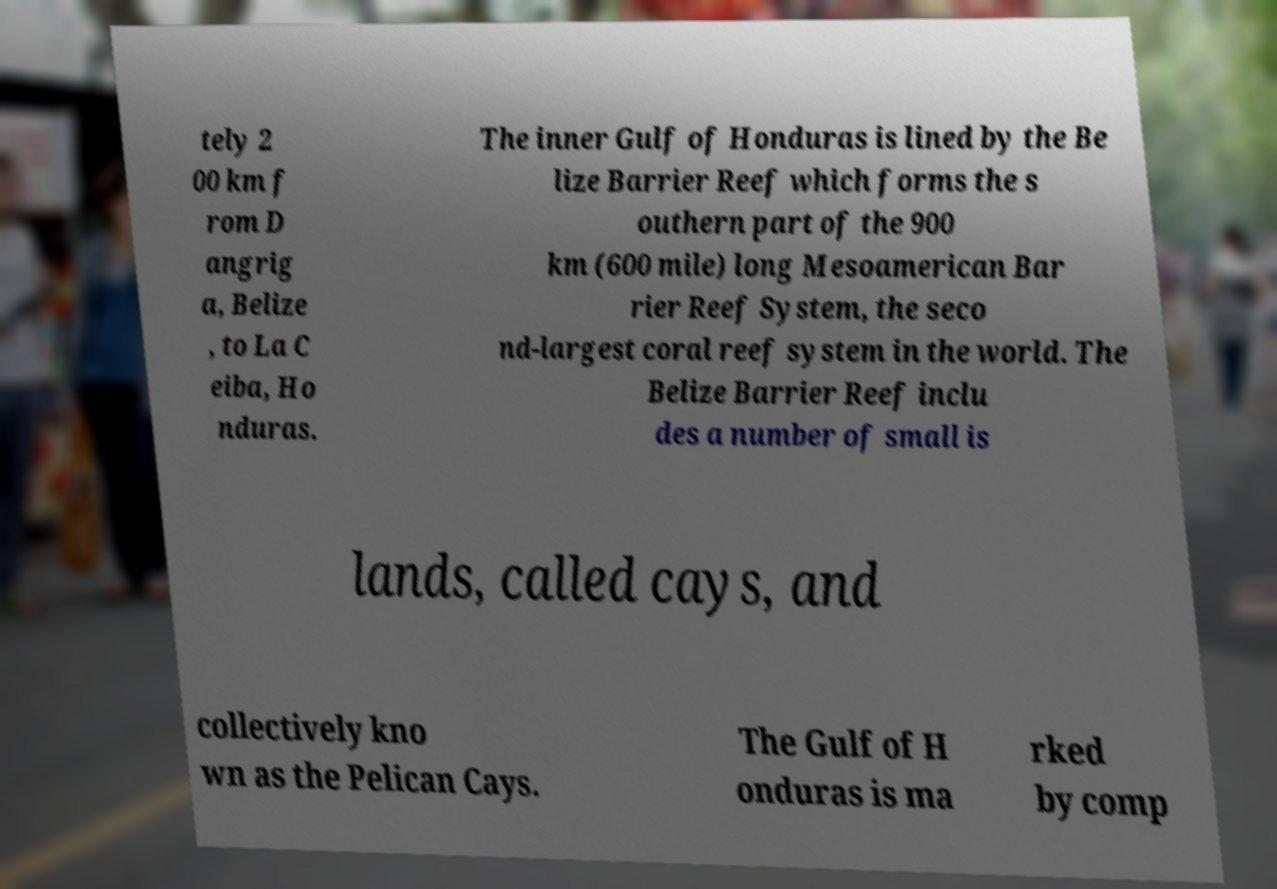There's text embedded in this image that I need extracted. Can you transcribe it verbatim? tely 2 00 km f rom D angrig a, Belize , to La C eiba, Ho nduras. The inner Gulf of Honduras is lined by the Be lize Barrier Reef which forms the s outhern part of the 900 km (600 mile) long Mesoamerican Bar rier Reef System, the seco nd-largest coral reef system in the world. The Belize Barrier Reef inclu des a number of small is lands, called cays, and collectively kno wn as the Pelican Cays. The Gulf of H onduras is ma rked by comp 